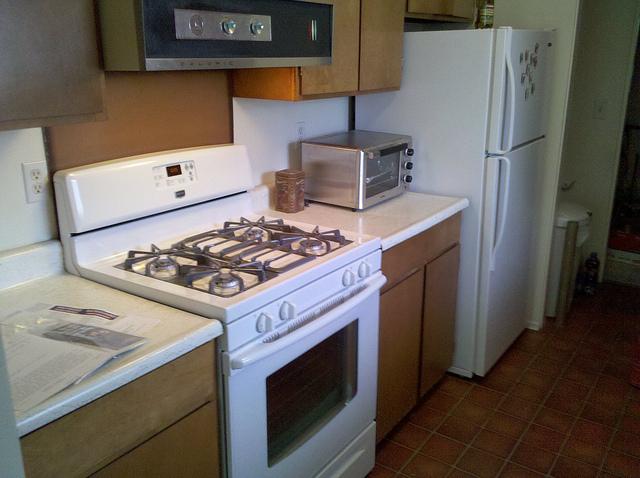What has a dial on it?
Give a very brief answer. Stove. Where is the oven power vent?
Write a very short answer. Above. What room is this?
Be succinct. Kitchen. Is this a new kitchen?
Keep it brief. No. Is the newer appliance on the top or bottom?
Answer briefly. Bottom. Are any of the stove's burners on?
Give a very brief answer. No. Is it a gas or electric stove?
Concise answer only. Gas. 